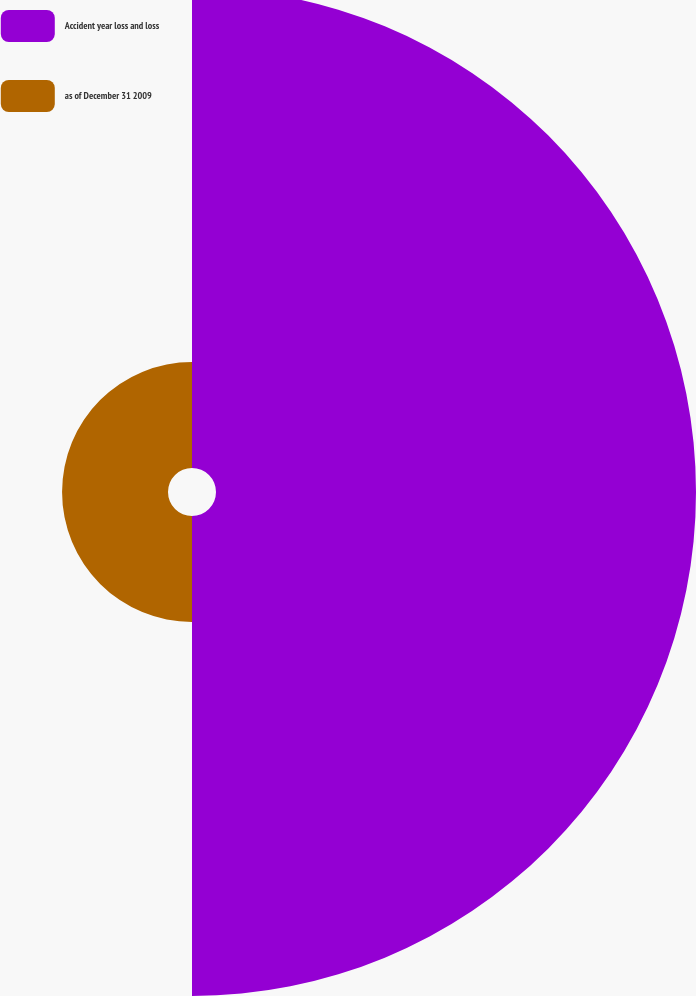Convert chart. <chart><loc_0><loc_0><loc_500><loc_500><pie_chart><fcel>Accident year loss and loss<fcel>as of December 31 2009<nl><fcel>81.92%<fcel>18.08%<nl></chart> 